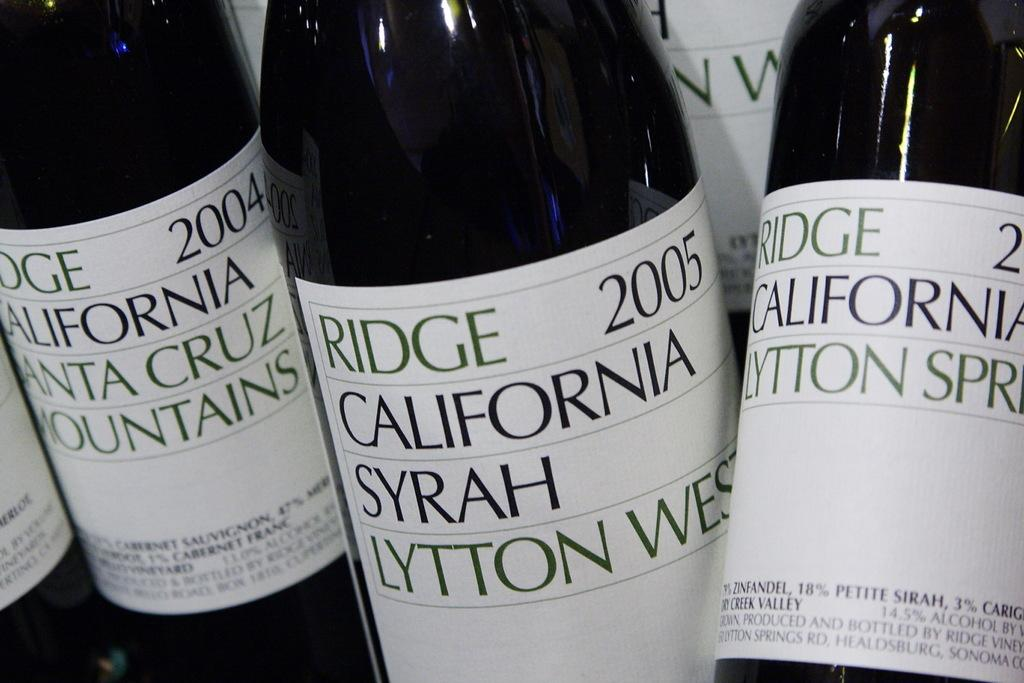<image>
Relay a brief, clear account of the picture shown. A bottle of California Syrah by Ridge from 2005. 